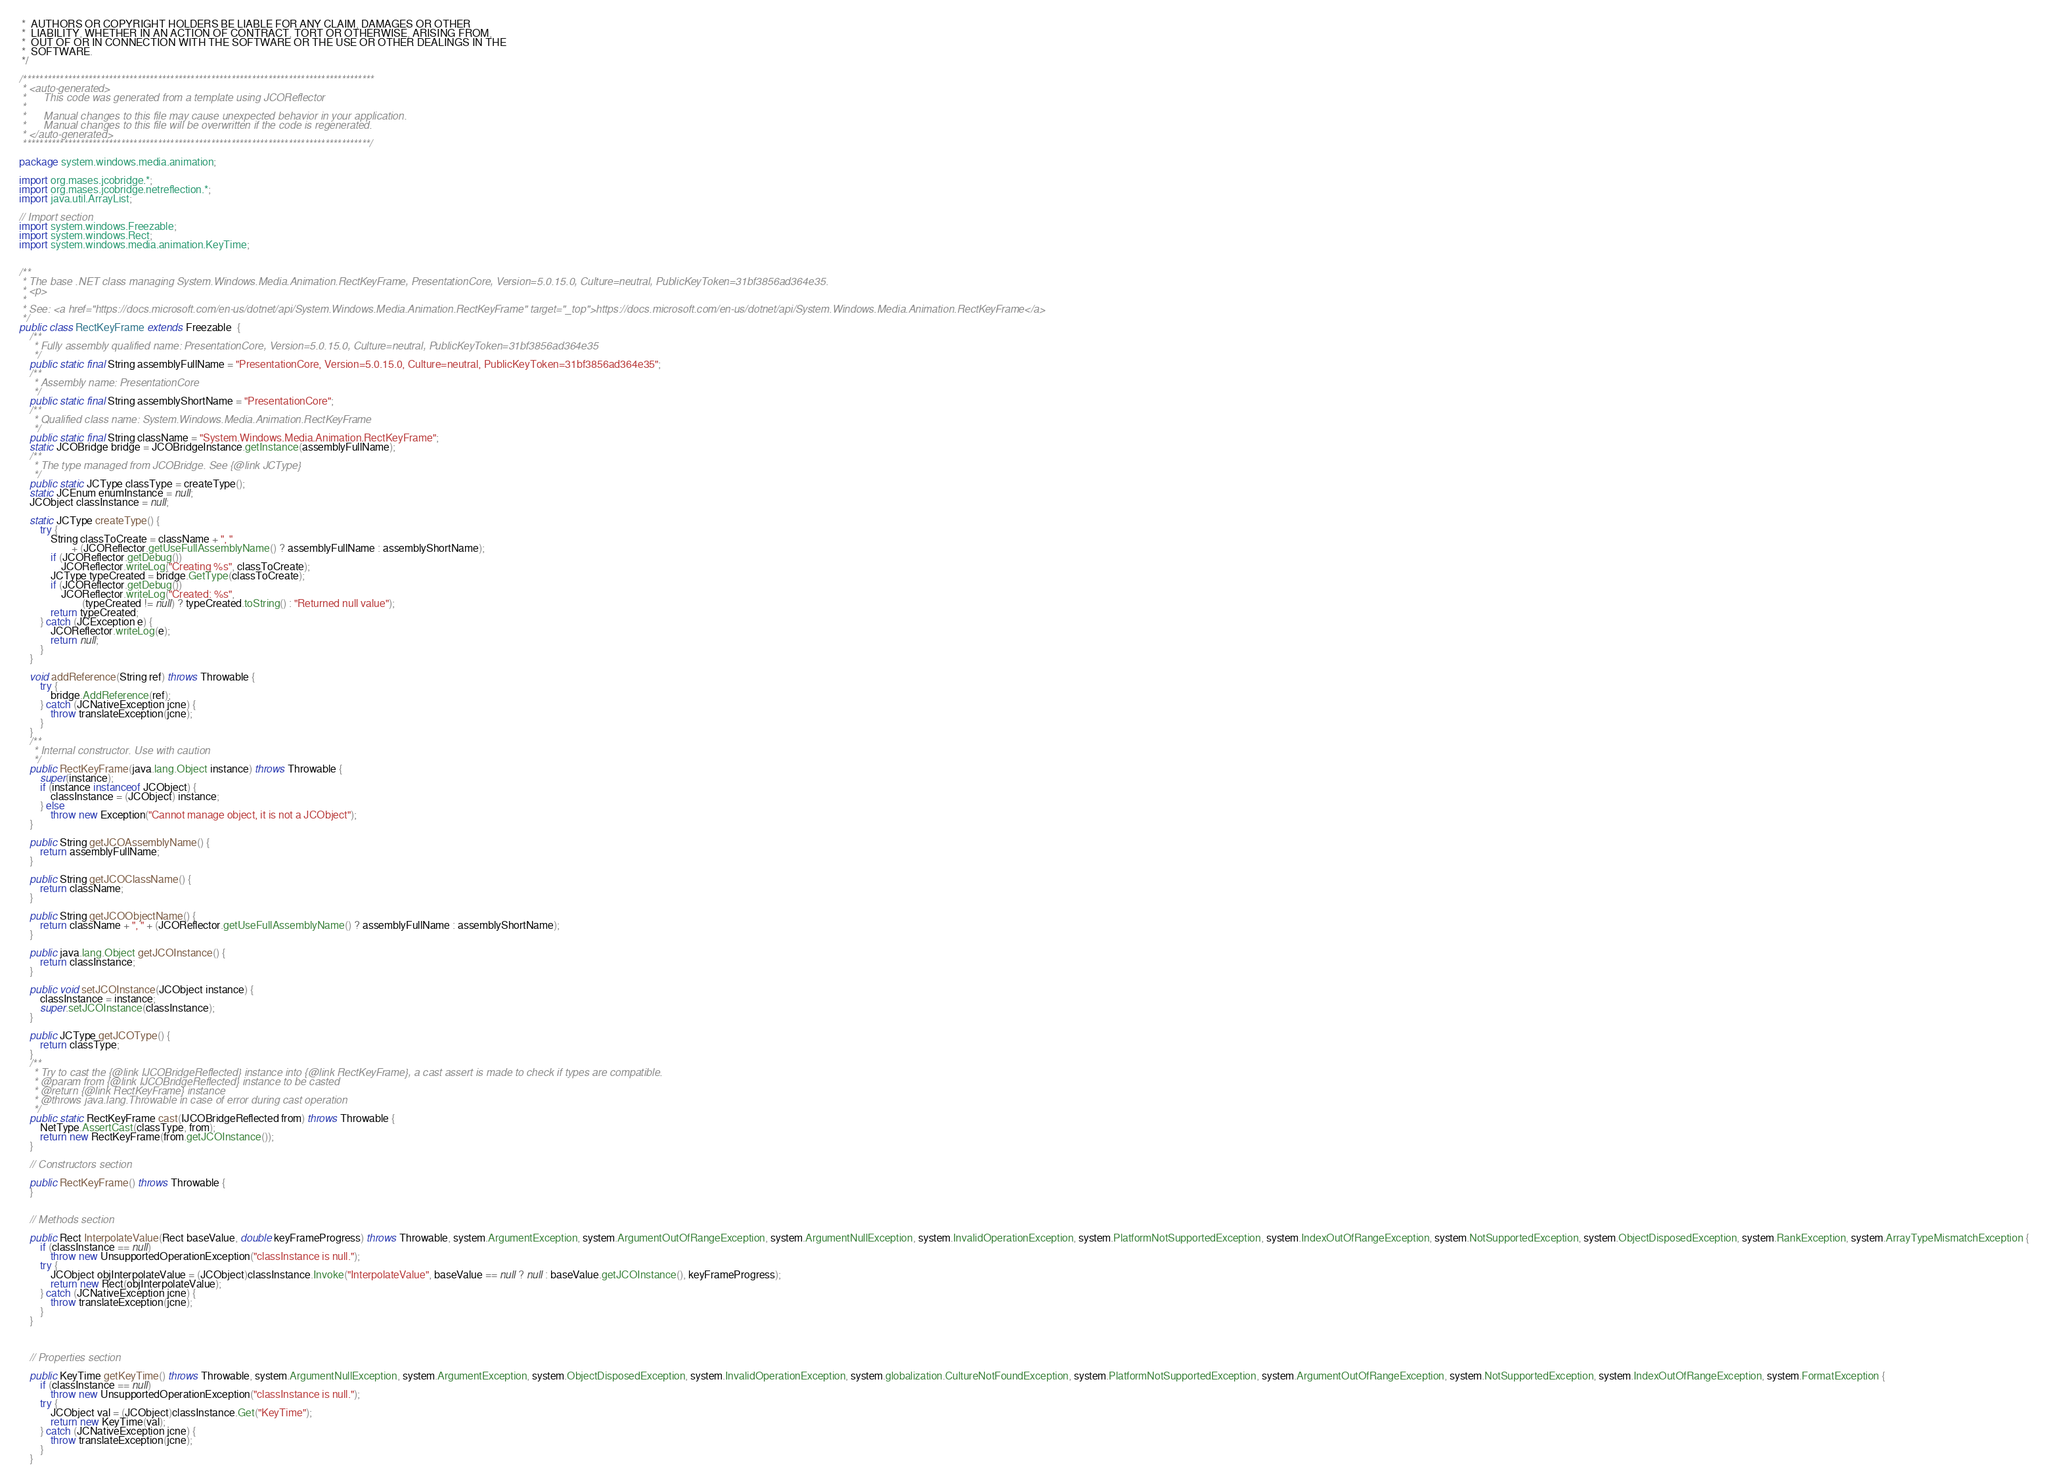Convert code to text. <code><loc_0><loc_0><loc_500><loc_500><_Java_> *  AUTHORS OR COPYRIGHT HOLDERS BE LIABLE FOR ANY CLAIM, DAMAGES OR OTHER
 *  LIABILITY, WHETHER IN AN ACTION OF CONTRACT, TORT OR OTHERWISE, ARISING FROM,
 *  OUT OF OR IN CONNECTION WITH THE SOFTWARE OR THE USE OR OTHER DEALINGS IN THE
 *  SOFTWARE.
 */

/**************************************************************************************
 * <auto-generated>
 *      This code was generated from a template using JCOReflector
 * 
 *      Manual changes to this file may cause unexpected behavior in your application.
 *      Manual changes to this file will be overwritten if the code is regenerated.
 * </auto-generated>
 *************************************************************************************/

package system.windows.media.animation;

import org.mases.jcobridge.*;
import org.mases.jcobridge.netreflection.*;
import java.util.ArrayList;

// Import section
import system.windows.Freezable;
import system.windows.Rect;
import system.windows.media.animation.KeyTime;


/**
 * The base .NET class managing System.Windows.Media.Animation.RectKeyFrame, PresentationCore, Version=5.0.15.0, Culture=neutral, PublicKeyToken=31bf3856ad364e35.
 * <p>
 * 
 * See: <a href="https://docs.microsoft.com/en-us/dotnet/api/System.Windows.Media.Animation.RectKeyFrame" target="_top">https://docs.microsoft.com/en-us/dotnet/api/System.Windows.Media.Animation.RectKeyFrame</a>
 */
public class RectKeyFrame extends Freezable  {
    /**
     * Fully assembly qualified name: PresentationCore, Version=5.0.15.0, Culture=neutral, PublicKeyToken=31bf3856ad364e35
     */
    public static final String assemblyFullName = "PresentationCore, Version=5.0.15.0, Culture=neutral, PublicKeyToken=31bf3856ad364e35";
    /**
     * Assembly name: PresentationCore
     */
    public static final String assemblyShortName = "PresentationCore";
    /**
     * Qualified class name: System.Windows.Media.Animation.RectKeyFrame
     */
    public static final String className = "System.Windows.Media.Animation.RectKeyFrame";
    static JCOBridge bridge = JCOBridgeInstance.getInstance(assemblyFullName);
    /**
     * The type managed from JCOBridge. See {@link JCType}
     */
    public static JCType classType = createType();
    static JCEnum enumInstance = null;
    JCObject classInstance = null;

    static JCType createType() {
        try {
            String classToCreate = className + ", "
                    + (JCOReflector.getUseFullAssemblyName() ? assemblyFullName : assemblyShortName);
            if (JCOReflector.getDebug())
                JCOReflector.writeLog("Creating %s", classToCreate);
            JCType typeCreated = bridge.GetType(classToCreate);
            if (JCOReflector.getDebug())
                JCOReflector.writeLog("Created: %s",
                        (typeCreated != null) ? typeCreated.toString() : "Returned null value");
            return typeCreated;
        } catch (JCException e) {
            JCOReflector.writeLog(e);
            return null;
        }
    }

    void addReference(String ref) throws Throwable {
        try {
            bridge.AddReference(ref);
        } catch (JCNativeException jcne) {
            throw translateException(jcne);
        }
    }
    /**
     * Internal constructor. Use with caution 
     */
    public RectKeyFrame(java.lang.Object instance) throws Throwable {
        super(instance);
        if (instance instanceof JCObject) {
            classInstance = (JCObject) instance;
        } else
            throw new Exception("Cannot manage object, it is not a JCObject");
    }

    public String getJCOAssemblyName() {
        return assemblyFullName;
    }

    public String getJCOClassName() {
        return className;
    }

    public String getJCOObjectName() {
        return className + ", " + (JCOReflector.getUseFullAssemblyName() ? assemblyFullName : assemblyShortName);
    }

    public java.lang.Object getJCOInstance() {
        return classInstance;
    }

    public void setJCOInstance(JCObject instance) {
        classInstance = instance;
        super.setJCOInstance(classInstance);
    }

    public JCType getJCOType() {
        return classType;
    }
    /**
     * Try to cast the {@link IJCOBridgeReflected} instance into {@link RectKeyFrame}, a cast assert is made to check if types are compatible.
     * @param from {@link IJCOBridgeReflected} instance to be casted
     * @return {@link RectKeyFrame} instance
     * @throws java.lang.Throwable in case of error during cast operation
     */
    public static RectKeyFrame cast(IJCOBridgeReflected from) throws Throwable {
        NetType.AssertCast(classType, from);
        return new RectKeyFrame(from.getJCOInstance());
    }

    // Constructors section
    
    public RectKeyFrame() throws Throwable {
    }

    
    // Methods section
    
    public Rect InterpolateValue(Rect baseValue, double keyFrameProgress) throws Throwable, system.ArgumentException, system.ArgumentOutOfRangeException, system.ArgumentNullException, system.InvalidOperationException, system.PlatformNotSupportedException, system.IndexOutOfRangeException, system.NotSupportedException, system.ObjectDisposedException, system.RankException, system.ArrayTypeMismatchException {
        if (classInstance == null)
            throw new UnsupportedOperationException("classInstance is null.");
        try {
            JCObject objInterpolateValue = (JCObject)classInstance.Invoke("InterpolateValue", baseValue == null ? null : baseValue.getJCOInstance(), keyFrameProgress);
            return new Rect(objInterpolateValue);
        } catch (JCNativeException jcne) {
            throw translateException(jcne);
        }
    }


    
    // Properties section
    
    public KeyTime getKeyTime() throws Throwable, system.ArgumentNullException, system.ArgumentException, system.ObjectDisposedException, system.InvalidOperationException, system.globalization.CultureNotFoundException, system.PlatformNotSupportedException, system.ArgumentOutOfRangeException, system.NotSupportedException, system.IndexOutOfRangeException, system.FormatException {
        if (classInstance == null)
            throw new UnsupportedOperationException("classInstance is null.");
        try {
            JCObject val = (JCObject)classInstance.Get("KeyTime");
            return new KeyTime(val);
        } catch (JCNativeException jcne) {
            throw translateException(jcne);
        }
    }
</code> 